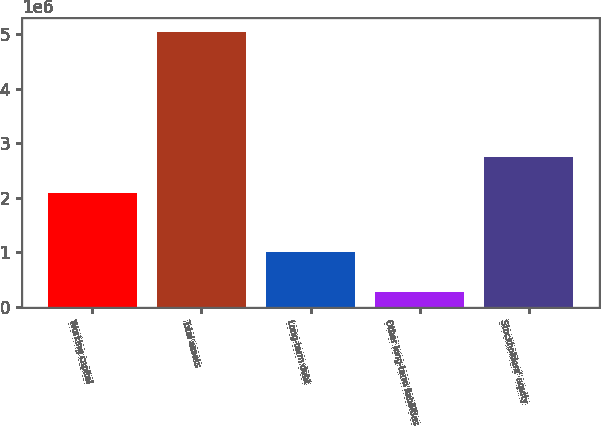Convert chart. <chart><loc_0><loc_0><loc_500><loc_500><bar_chart><fcel>Working capital<fcel>Total assets<fcel>Long-term debt<fcel>Other long-term liabilities<fcel>Stockholders' equity<nl><fcel>2.07779e+06<fcel>5.03735e+06<fcel>993870<fcel>266438<fcel>2.75268e+06<nl></chart> 